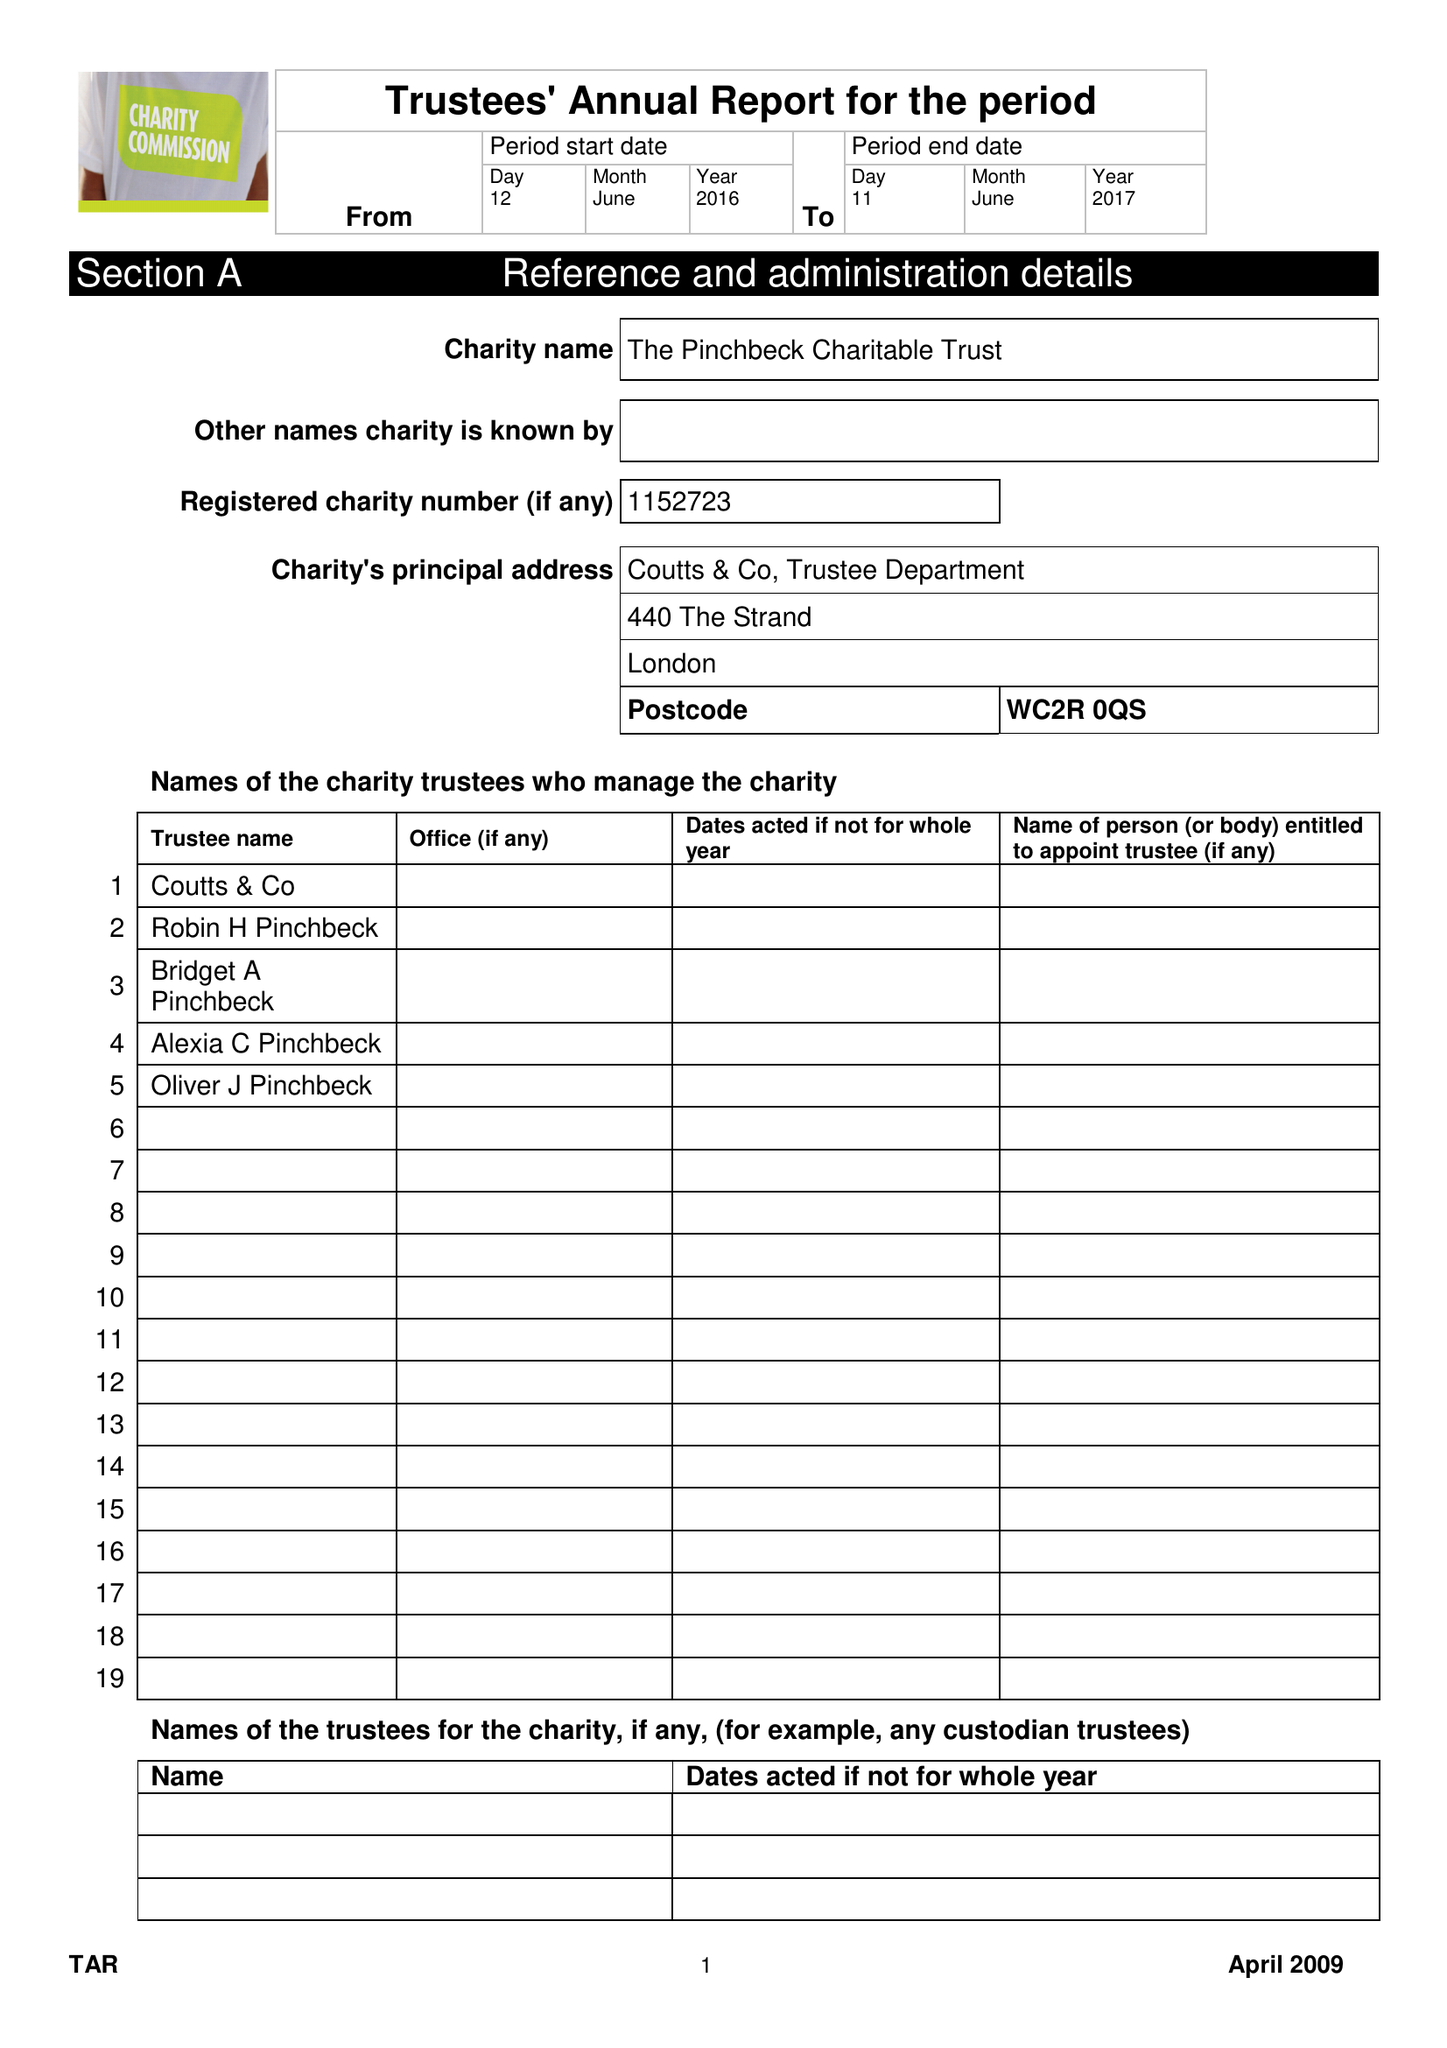What is the value for the address__street_line?
Answer the question using a single word or phrase. 17 OLD QUEEN STREET 